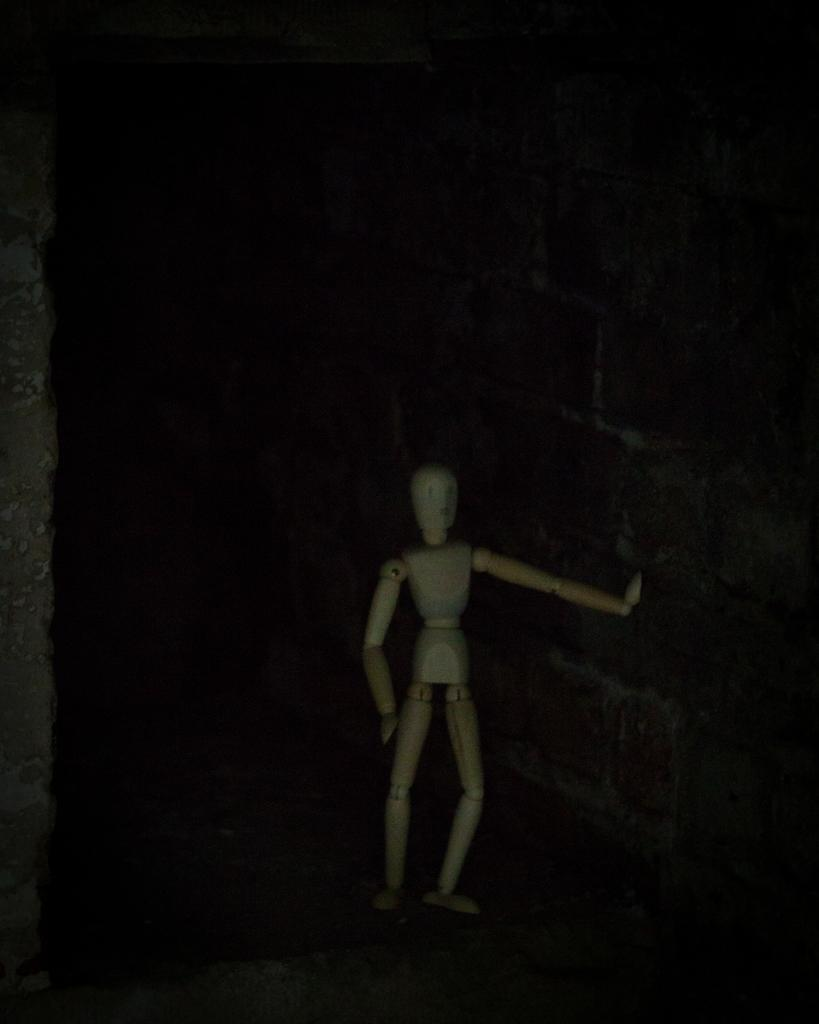What is the main subject in the center of the image? There is a toy in the center of the image. What can be seen in the background of the image? There is a wall visible in the background of the image. What type of bun is being used to react to the toy in the image? There is no bun or reaction present in the image; it only features a toy and a wall in the background. 